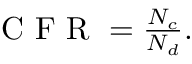<formula> <loc_0><loc_0><loc_500><loc_500>\begin{array} { r } { C F R = \frac { N _ { c } } { N _ { d } } . } \end{array}</formula> 